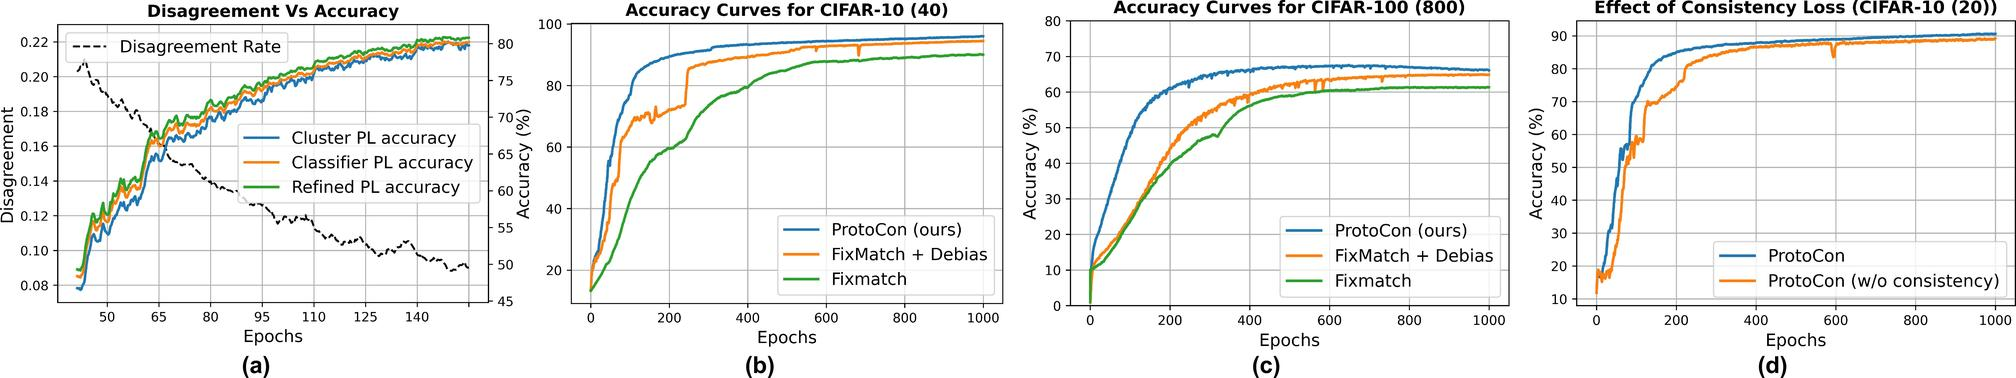Can you explain the relationship between the Disagreement Rate and accuracies of different models as shown in figure (a)? In figure (a), as the Disagreement Rate decreases, the accuracies of the cluster, classifier, and refined pseudo label accuracies show mild increases. This suggests that a lower Disagreement Rate is associated with higher accuracy across these models, potentially indicating that more consistent model predictions correlate with better overall performance. 